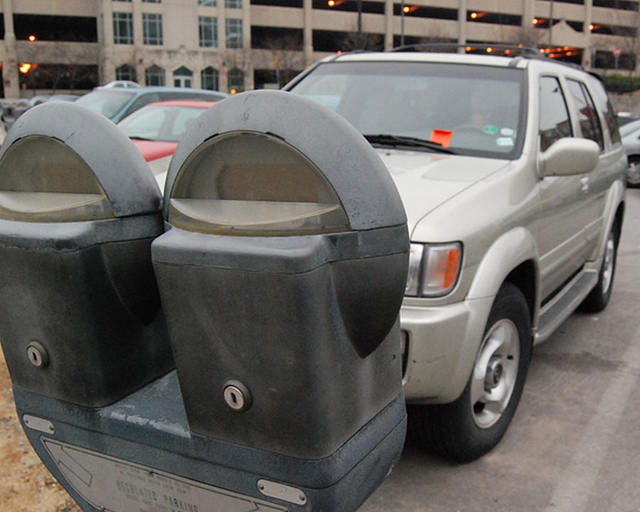Please transcribe the text in this image. PARKING 